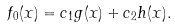<formula> <loc_0><loc_0><loc_500><loc_500>f _ { 0 } ( x ) = c _ { 1 } g ( x ) + c _ { 2 } h ( x ) .</formula> 